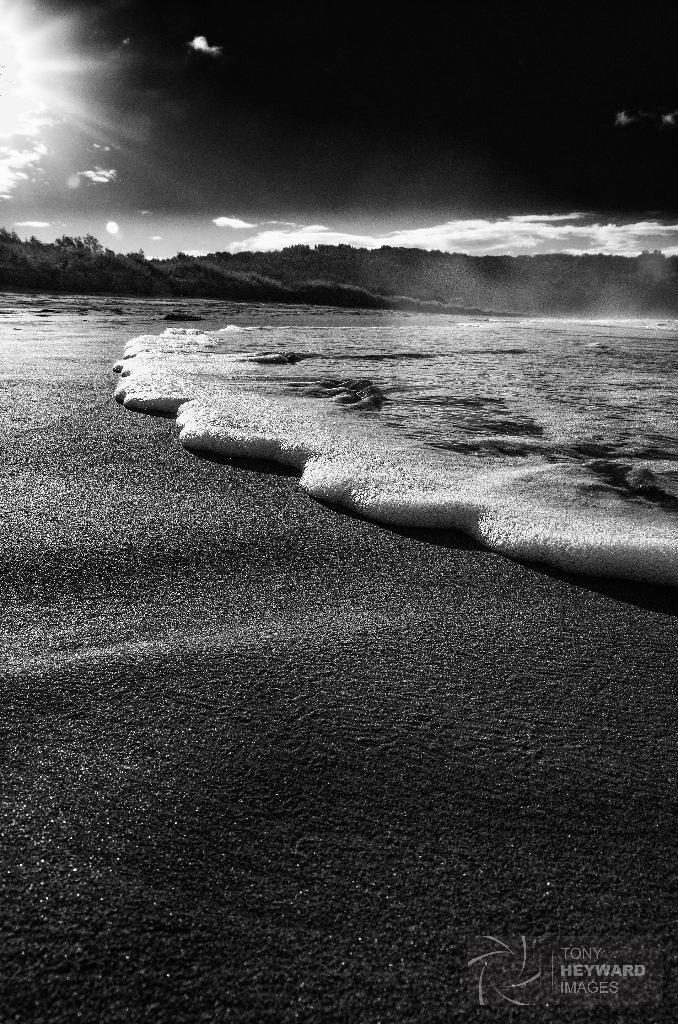What is the color scheme of the image? The image is black and white. What can be seen in the sky in the image? Clouds are present in the sky. What type of vegetation is visible in the image? There are trees in the image. What large body of water is visible in the image? An ocean is visible in the image. What type of yarn is being used to create the example of a yoke in the image? There is no yarn or yoke present in the image; it features a black and white scene with sky, clouds, trees, and an ocean. 